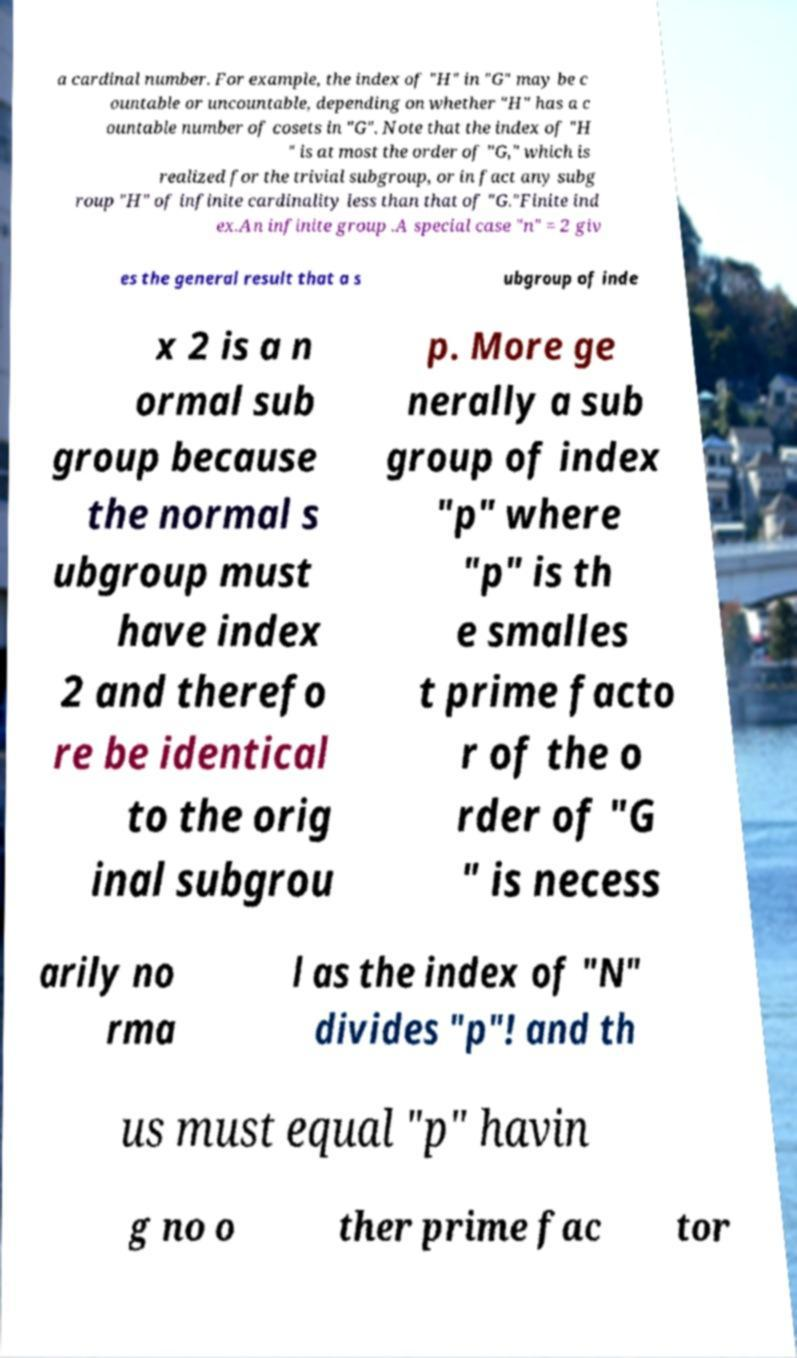Can you accurately transcribe the text from the provided image for me? a cardinal number. For example, the index of "H" in "G" may be c ountable or uncountable, depending on whether "H" has a c ountable number of cosets in "G". Note that the index of "H " is at most the order of "G," which is realized for the trivial subgroup, or in fact any subg roup "H" of infinite cardinality less than that of "G."Finite ind ex.An infinite group .A special case "n" = 2 giv es the general result that a s ubgroup of inde x 2 is a n ormal sub group because the normal s ubgroup must have index 2 and therefo re be identical to the orig inal subgrou p. More ge nerally a sub group of index "p" where "p" is th e smalles t prime facto r of the o rder of "G " is necess arily no rma l as the index of "N" divides "p"! and th us must equal "p" havin g no o ther prime fac tor 